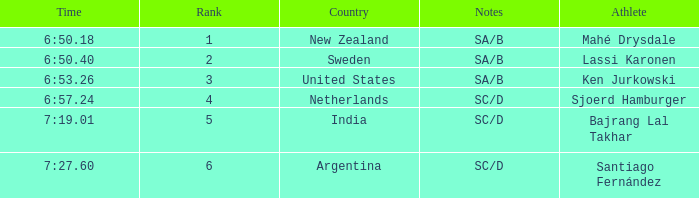What is the highest rank for the team that raced a time of 6:50.40? 2.0. 